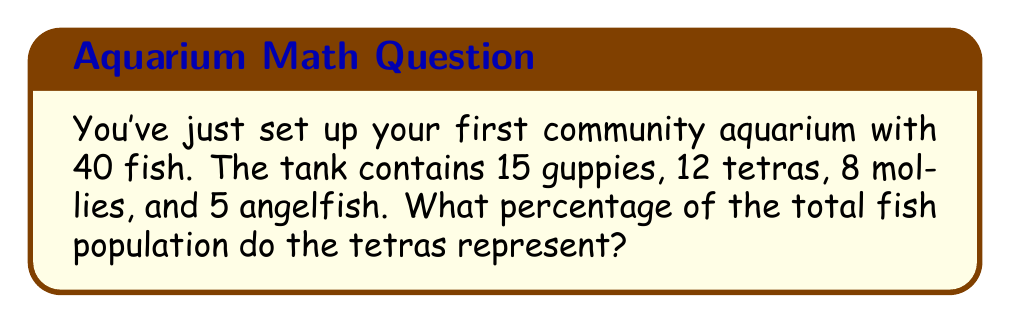Provide a solution to this math problem. To solve this problem, we'll follow these steps:

1. Identify the total number of fish:
   Total fish = 15 + 12 + 8 + 5 = 40

2. Identify the number of tetras:
   Number of tetras = 12

3. Calculate the percentage using the formula:
   $$ \text{Percentage} = \frac{\text{Number of tetras}}{\text{Total number of fish}} \times 100\% $$

4. Plug in the values:
   $$ \text{Percentage} = \frac{12}{40} \times 100\% $$

5. Simplify the fraction:
   $$ \text{Percentage} = \frac{3}{10} \times 100\% $$

6. Perform the multiplication:
   $$ \text{Percentage} = 0.3 \times 100\% = 30\% $$

Therefore, tetras represent 30% of the total fish population in your community aquarium.
Answer: 30% 